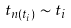Convert formula to latex. <formula><loc_0><loc_0><loc_500><loc_500>t _ { n ( t _ { i } ) } \sim t _ { i }</formula> 